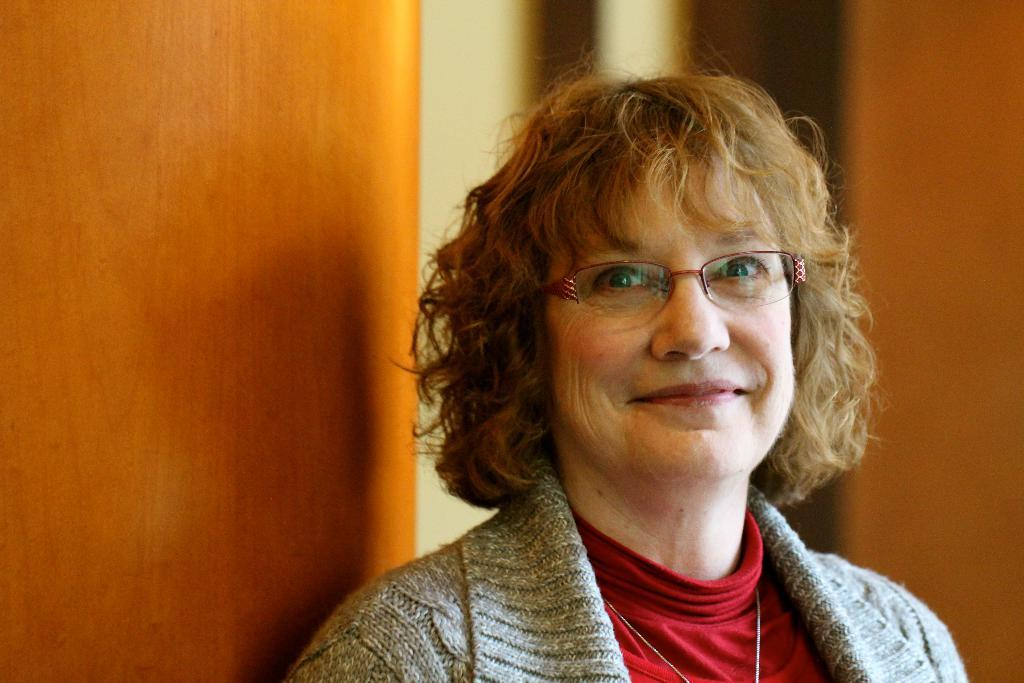Who is present in the image? There is a woman in the picture. What is the woman wearing on her face? The woman is wearing spectacles. What type of clothing is the woman wearing? The woman is wearing a coat. What can be seen on the left side of the image? There is a door on the left side of the image. What type of calculator is the woman holding in the image? There is no calculator present in the image. Can you tell me how many goats are visible in the image? There are no goats present in the image. 